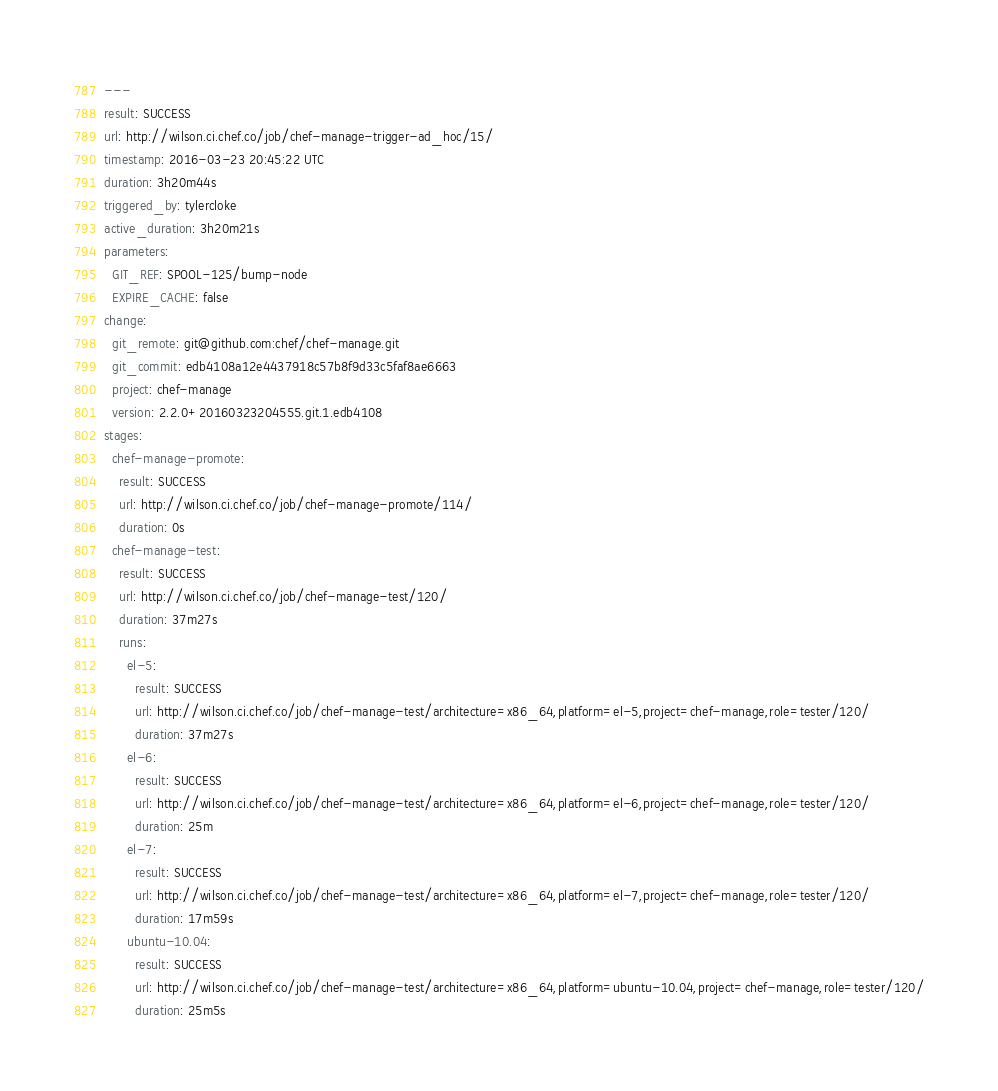Convert code to text. <code><loc_0><loc_0><loc_500><loc_500><_YAML_>---
result: SUCCESS
url: http://wilson.ci.chef.co/job/chef-manage-trigger-ad_hoc/15/
timestamp: 2016-03-23 20:45:22 UTC
duration: 3h20m44s
triggered_by: tylercloke
active_duration: 3h20m21s
parameters:
  GIT_REF: SPOOL-125/bump-node
  EXPIRE_CACHE: false
change:
  git_remote: git@github.com:chef/chef-manage.git
  git_commit: edb4108a12e4437918c57b8f9d33c5faf8ae6663
  project: chef-manage
  version: 2.2.0+20160323204555.git.1.edb4108
stages:
  chef-manage-promote:
    result: SUCCESS
    url: http://wilson.ci.chef.co/job/chef-manage-promote/114/
    duration: 0s
  chef-manage-test:
    result: SUCCESS
    url: http://wilson.ci.chef.co/job/chef-manage-test/120/
    duration: 37m27s
    runs:
      el-5:
        result: SUCCESS
        url: http://wilson.ci.chef.co/job/chef-manage-test/architecture=x86_64,platform=el-5,project=chef-manage,role=tester/120/
        duration: 37m27s
      el-6:
        result: SUCCESS
        url: http://wilson.ci.chef.co/job/chef-manage-test/architecture=x86_64,platform=el-6,project=chef-manage,role=tester/120/
        duration: 25m
      el-7:
        result: SUCCESS
        url: http://wilson.ci.chef.co/job/chef-manage-test/architecture=x86_64,platform=el-7,project=chef-manage,role=tester/120/
        duration: 17m59s
      ubuntu-10.04:
        result: SUCCESS
        url: http://wilson.ci.chef.co/job/chef-manage-test/architecture=x86_64,platform=ubuntu-10.04,project=chef-manage,role=tester/120/
        duration: 25m5s</code> 